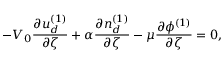Convert formula to latex. <formula><loc_0><loc_0><loc_500><loc_500>- V _ { 0 } \frac { \partial u _ { d } ^ { ( 1 ) } } { \partial \zeta } + \alpha \frac { \partial n _ { d } ^ { ( 1 ) } } { \partial \zeta } - \mu \frac { \partial \phi ^ { ( 1 ) } } { \partial \zeta } = 0 ,</formula> 